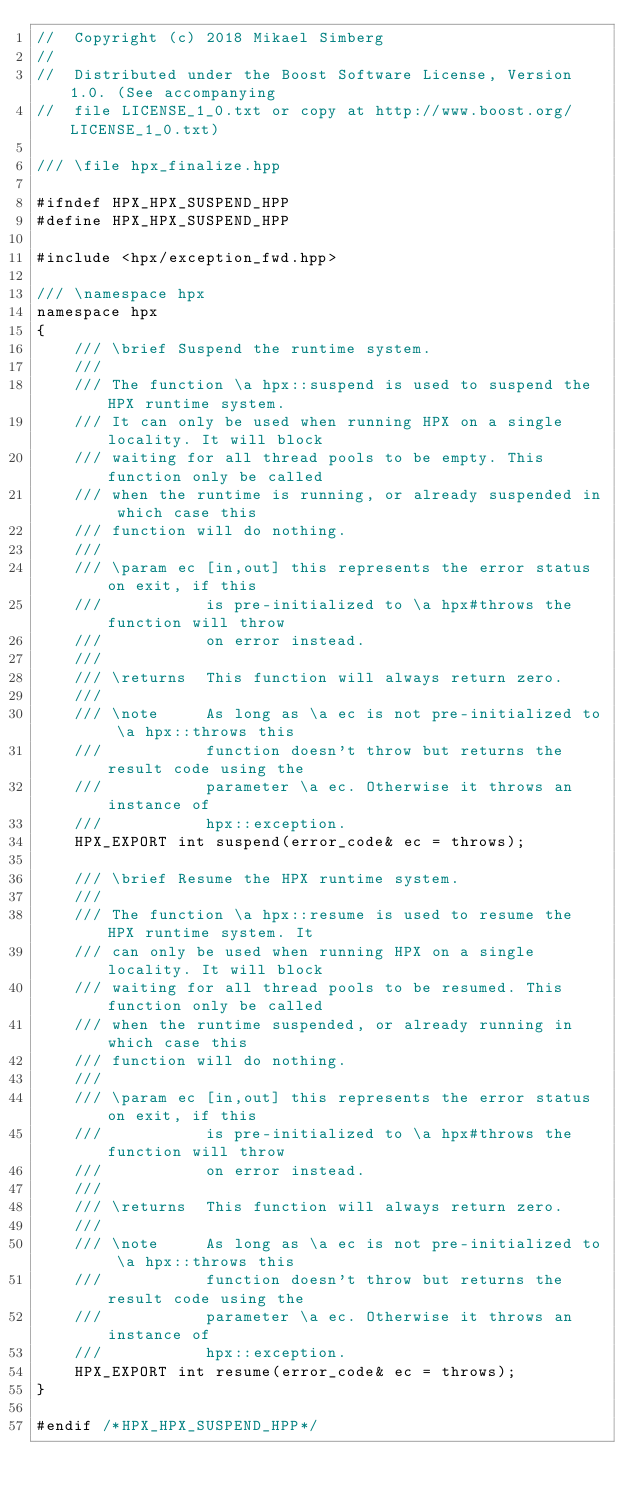Convert code to text. <code><loc_0><loc_0><loc_500><loc_500><_C++_>//  Copyright (c) 2018 Mikael Simberg
//
//  Distributed under the Boost Software License, Version 1.0. (See accompanying
//  file LICENSE_1_0.txt or copy at http://www.boost.org/LICENSE_1_0.txt)

/// \file hpx_finalize.hpp

#ifndef HPX_HPX_SUSPEND_HPP
#define HPX_HPX_SUSPEND_HPP

#include <hpx/exception_fwd.hpp>

/// \namespace hpx
namespace hpx
{
    /// \brief Suspend the runtime system.
    ///
    /// The function \a hpx::suspend is used to suspend the HPX runtime system.
    /// It can only be used when running HPX on a single locality. It will block
    /// waiting for all thread pools to be empty. This function only be called
    /// when the runtime is running, or already suspended in which case this
    /// function will do nothing.
    ///
    /// \param ec [in,out] this represents the error status on exit, if this
    ///           is pre-initialized to \a hpx#throws the function will throw
    ///           on error instead.
    ///
    /// \returns  This function will always return zero.
    ///
    /// \note     As long as \a ec is not pre-initialized to \a hpx::throws this
    ///           function doesn't throw but returns the result code using the
    ///           parameter \a ec. Otherwise it throws an instance of
    ///           hpx::exception.
    HPX_EXPORT int suspend(error_code& ec = throws);

    /// \brief Resume the HPX runtime system.
    ///
    /// The function \a hpx::resume is used to resume the HPX runtime system. It
    /// can only be used when running HPX on a single locality. It will block
    /// waiting for all thread pools to be resumed. This function only be called
    /// when the runtime suspended, or already running in which case this
    /// function will do nothing.
    ///
    /// \param ec [in,out] this represents the error status on exit, if this
    ///           is pre-initialized to \a hpx#throws the function will throw
    ///           on error instead.
    ///
    /// \returns  This function will always return zero.
    ///
    /// \note     As long as \a ec is not pre-initialized to \a hpx::throws this
    ///           function doesn't throw but returns the result code using the
    ///           parameter \a ec. Otherwise it throws an instance of
    ///           hpx::exception.
    HPX_EXPORT int resume(error_code& ec = throws);
}

#endif /*HPX_HPX_SUSPEND_HPP*/
</code> 